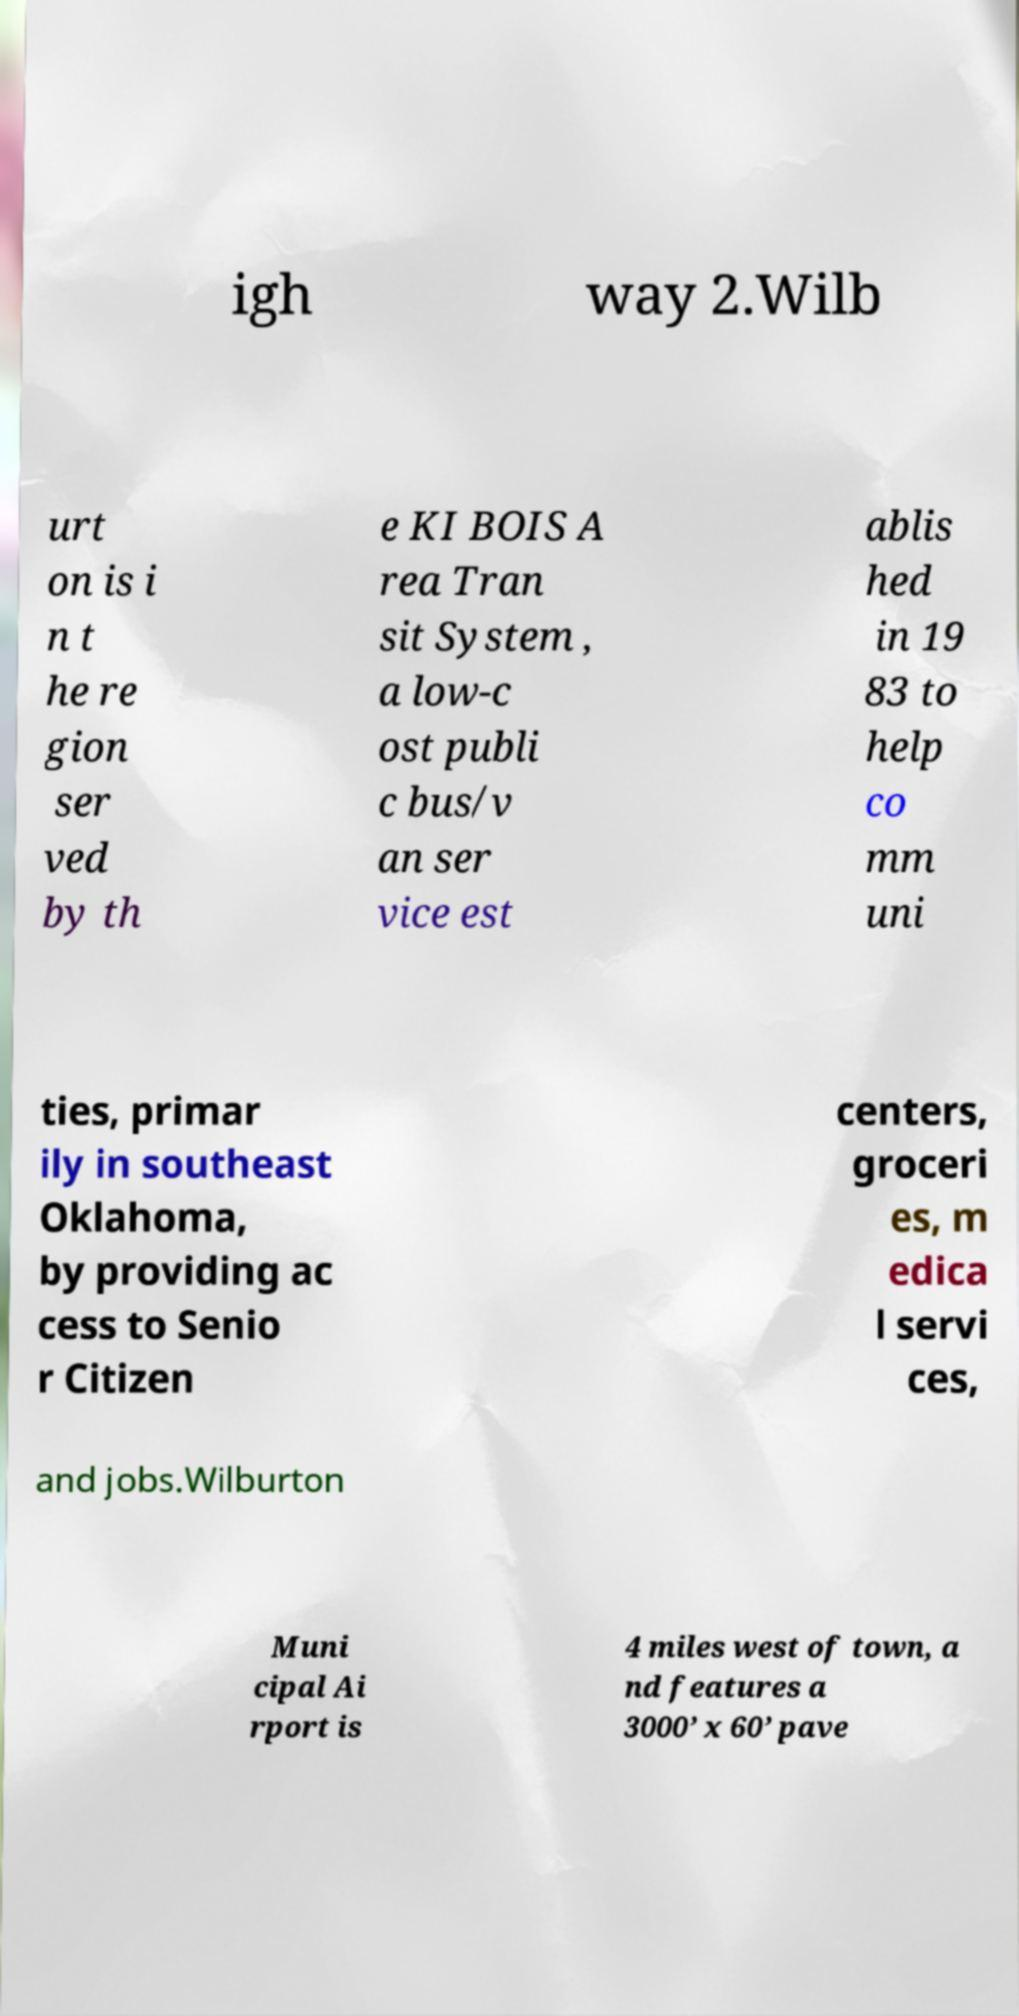I need the written content from this picture converted into text. Can you do that? igh way 2.Wilb urt on is i n t he re gion ser ved by th e KI BOIS A rea Tran sit System , a low-c ost publi c bus/v an ser vice est ablis hed in 19 83 to help co mm uni ties, primar ily in southeast Oklahoma, by providing ac cess to Senio r Citizen centers, groceri es, m edica l servi ces, and jobs.Wilburton Muni cipal Ai rport is 4 miles west of town, a nd features a 3000’ x 60’ pave 